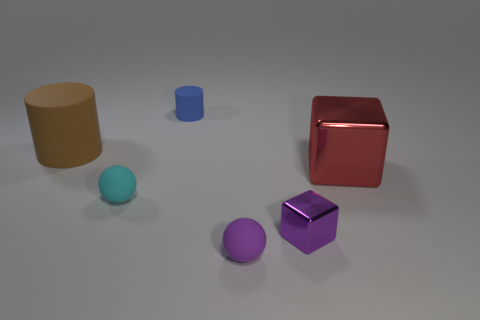Add 3 cyan matte objects. How many objects exist? 9 Subtract all cylinders. How many objects are left? 4 Add 1 purple shiny cubes. How many purple shiny cubes exist? 2 Subtract 0 red cylinders. How many objects are left? 6 Subtract all cyan rubber cylinders. Subtract all tiny blue cylinders. How many objects are left? 5 Add 6 red metallic blocks. How many red metallic blocks are left? 7 